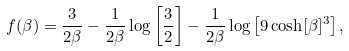<formula> <loc_0><loc_0><loc_500><loc_500>f ( \beta ) = \frac { 3 } { 2 \beta } - \frac { 1 } { 2 \beta } \log \left [ \frac { 3 } { 2 } \right ] - \frac { 1 } { 2 \beta } \log \left [ 9 \cosh [ \beta ] ^ { 3 } \right ] ,</formula> 